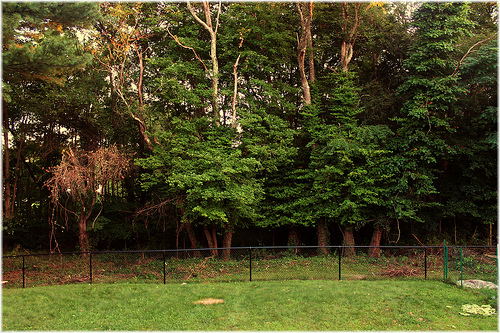<image>
Is there a tree to the left of the fence? Yes. From this viewpoint, the tree is positioned to the left side relative to the fence. 